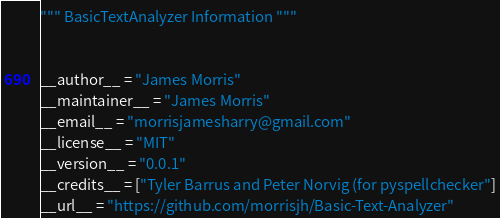Convert code to text. <code><loc_0><loc_0><loc_500><loc_500><_Python_>""" BasicTextAnalyzer Information """


__author__ = "James Morris"
__maintainer__ = "James Morris"
__email__ = "morrisjamesharry@gmail.com"
__license__ = "MIT"
__version__ = "0.0.1"
__credits__ = ["Tyler Barrus and Peter Norvig (for pyspellchecker"]
__url__ = "https://github.com/morrisjh/Basic-Text-Analyzer"
</code> 